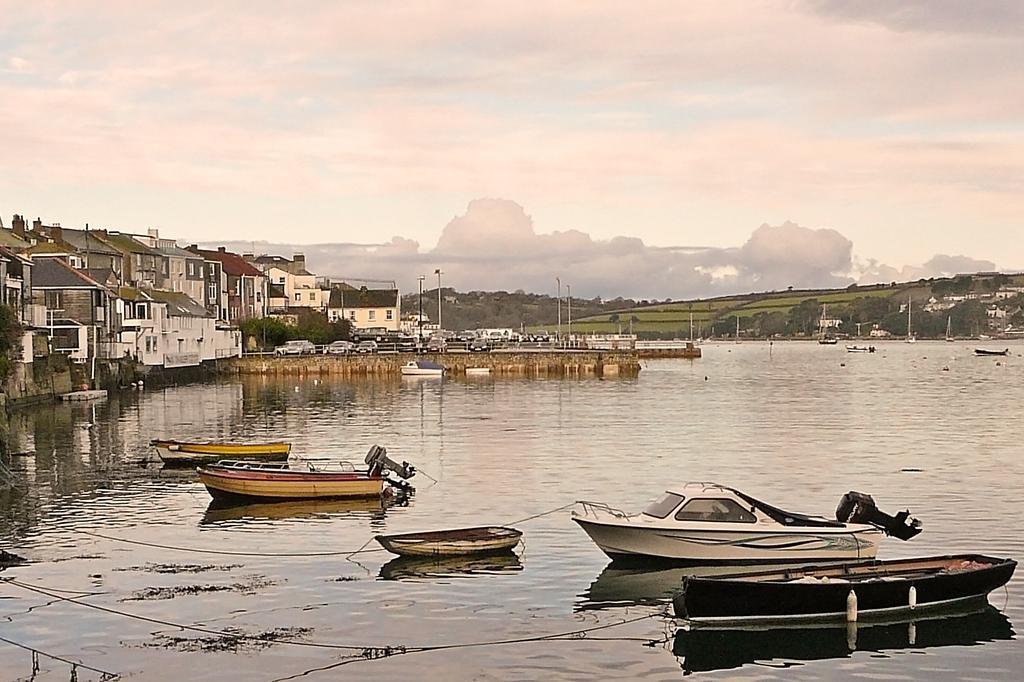How would you summarize this image in a sentence or two? In this picture we can see some boats are in the water, around we can see some building, vehicles and some trees and grass. 